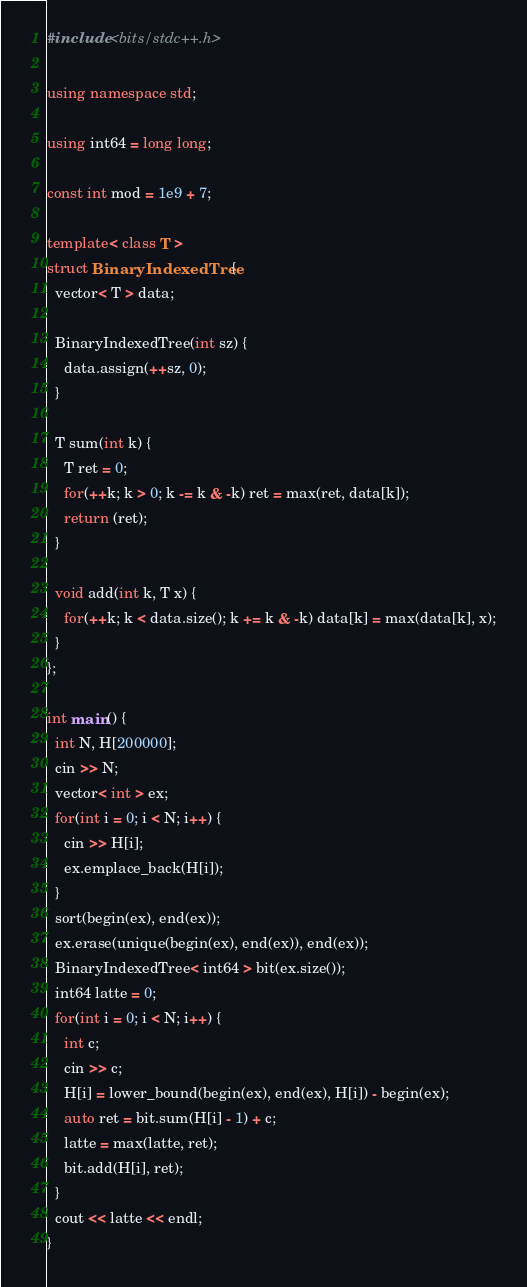<code> <loc_0><loc_0><loc_500><loc_500><_C++_>#include <bits/stdc++.h>

using namespace std;

using int64 = long long;

const int mod = 1e9 + 7;

template< class T >
struct BinaryIndexedTree {
  vector< T > data;

  BinaryIndexedTree(int sz) {
    data.assign(++sz, 0);
  }

  T sum(int k) {
    T ret = 0;
    for(++k; k > 0; k -= k & -k) ret = max(ret, data[k]);
    return (ret);
  }

  void add(int k, T x) {
    for(++k; k < data.size(); k += k & -k) data[k] = max(data[k], x);
  }
};

int main() {
  int N, H[200000];
  cin >> N;
  vector< int > ex;
  for(int i = 0; i < N; i++) {
    cin >> H[i];
    ex.emplace_back(H[i]);
  }
  sort(begin(ex), end(ex));
  ex.erase(unique(begin(ex), end(ex)), end(ex));
  BinaryIndexedTree< int64 > bit(ex.size());
  int64 latte = 0;
  for(int i = 0; i < N; i++) {
    int c;
    cin >> c;
    H[i] = lower_bound(begin(ex), end(ex), H[i]) - begin(ex);
    auto ret = bit.sum(H[i] - 1) + c;
    latte = max(latte, ret);
    bit.add(H[i], ret);
  }
  cout << latte << endl;
}

</code> 